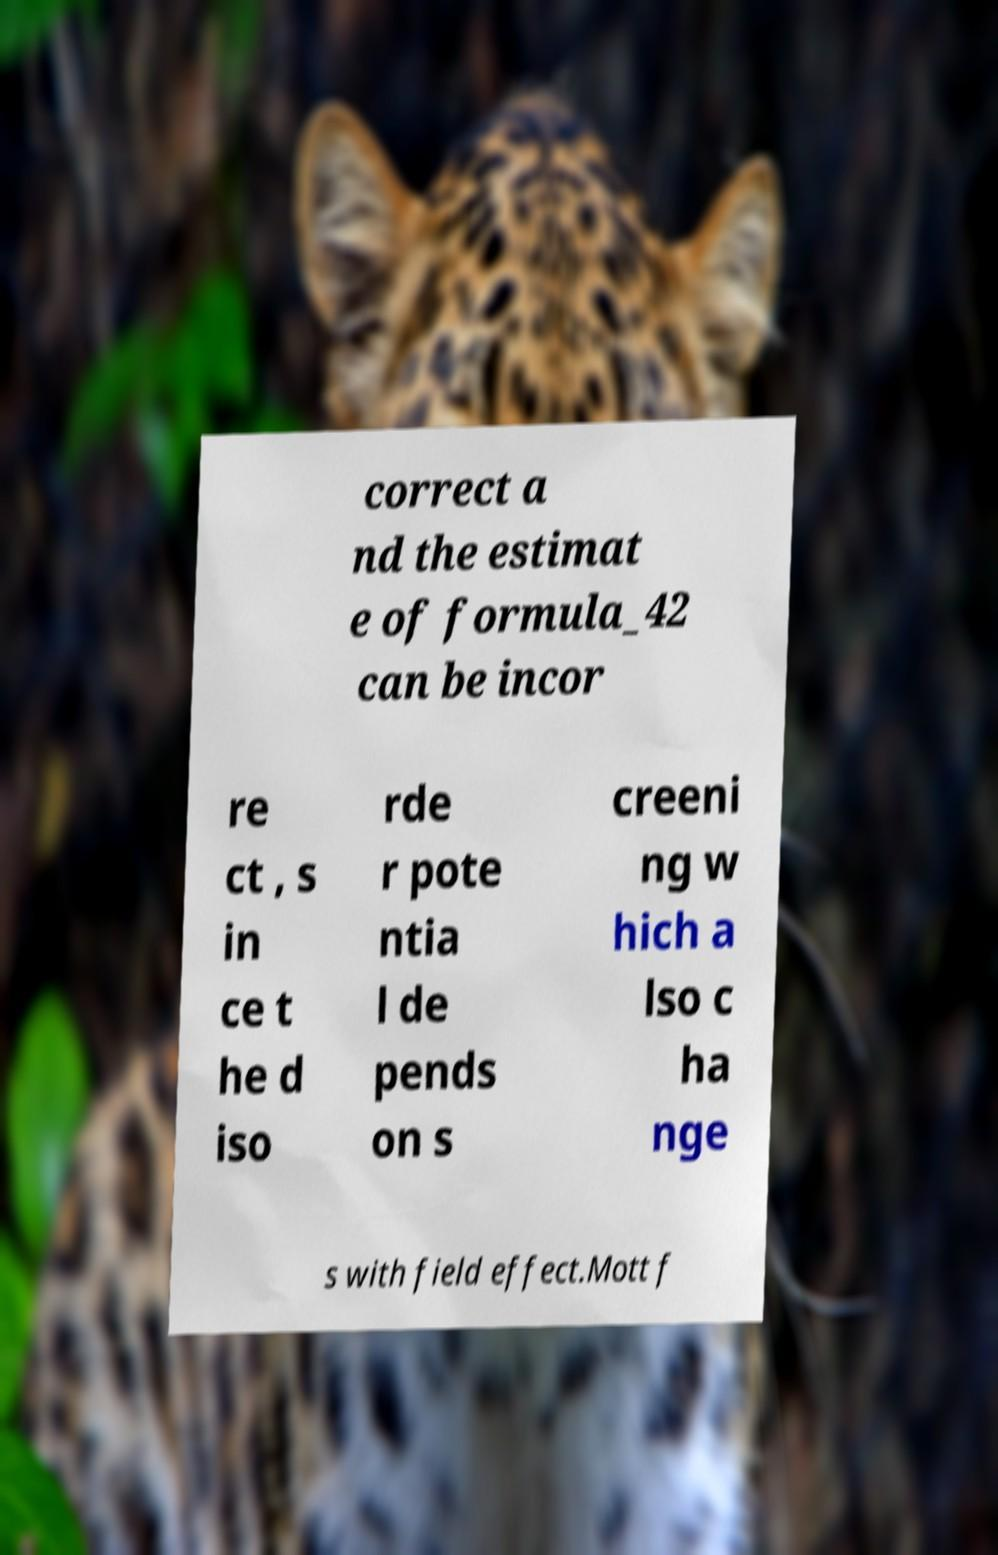Can you accurately transcribe the text from the provided image for me? correct a nd the estimat e of formula_42 can be incor re ct , s in ce t he d iso rde r pote ntia l de pends on s creeni ng w hich a lso c ha nge s with field effect.Mott f 